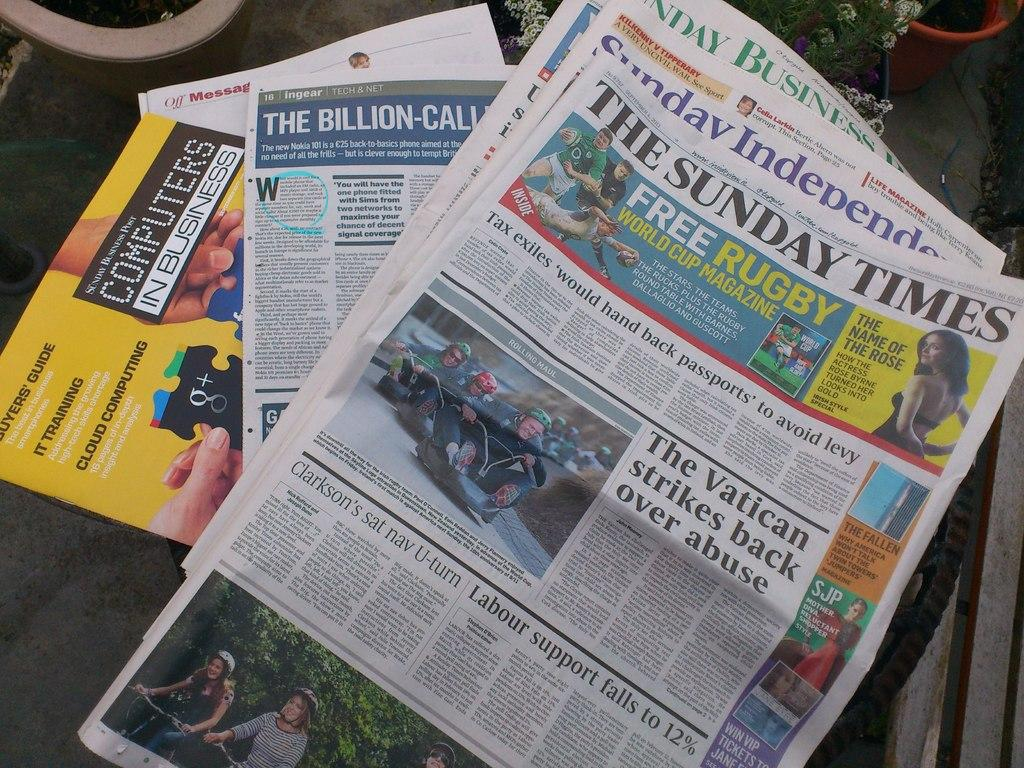<image>
Summarize the visual content of the image. The Sunday Times Newspaper lying on a table. 